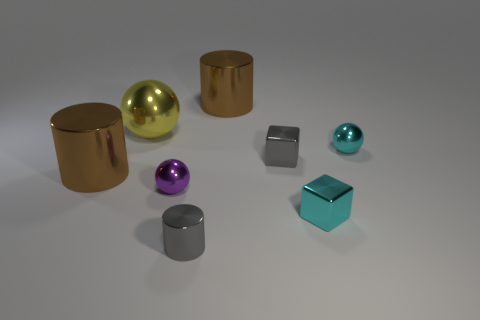Add 1 big balls. How many objects exist? 9 Subtract all cubes. How many objects are left? 6 Subtract all tiny blocks. Subtract all big metal cylinders. How many objects are left? 4 Add 1 cyan balls. How many cyan balls are left? 2 Add 8 big cylinders. How many big cylinders exist? 10 Subtract 1 purple spheres. How many objects are left? 7 